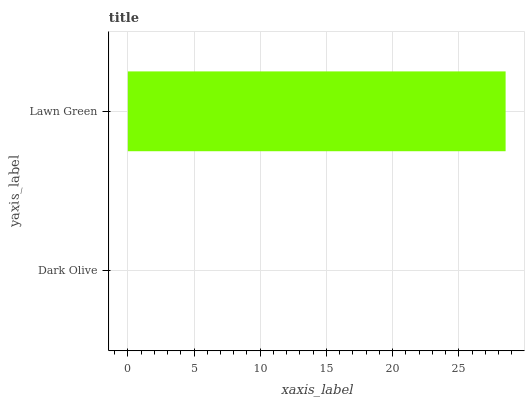Is Dark Olive the minimum?
Answer yes or no. Yes. Is Lawn Green the maximum?
Answer yes or no. Yes. Is Lawn Green the minimum?
Answer yes or no. No. Is Lawn Green greater than Dark Olive?
Answer yes or no. Yes. Is Dark Olive less than Lawn Green?
Answer yes or no. Yes. Is Dark Olive greater than Lawn Green?
Answer yes or no. No. Is Lawn Green less than Dark Olive?
Answer yes or no. No. Is Lawn Green the high median?
Answer yes or no. Yes. Is Dark Olive the low median?
Answer yes or no. Yes. Is Dark Olive the high median?
Answer yes or no. No. Is Lawn Green the low median?
Answer yes or no. No. 